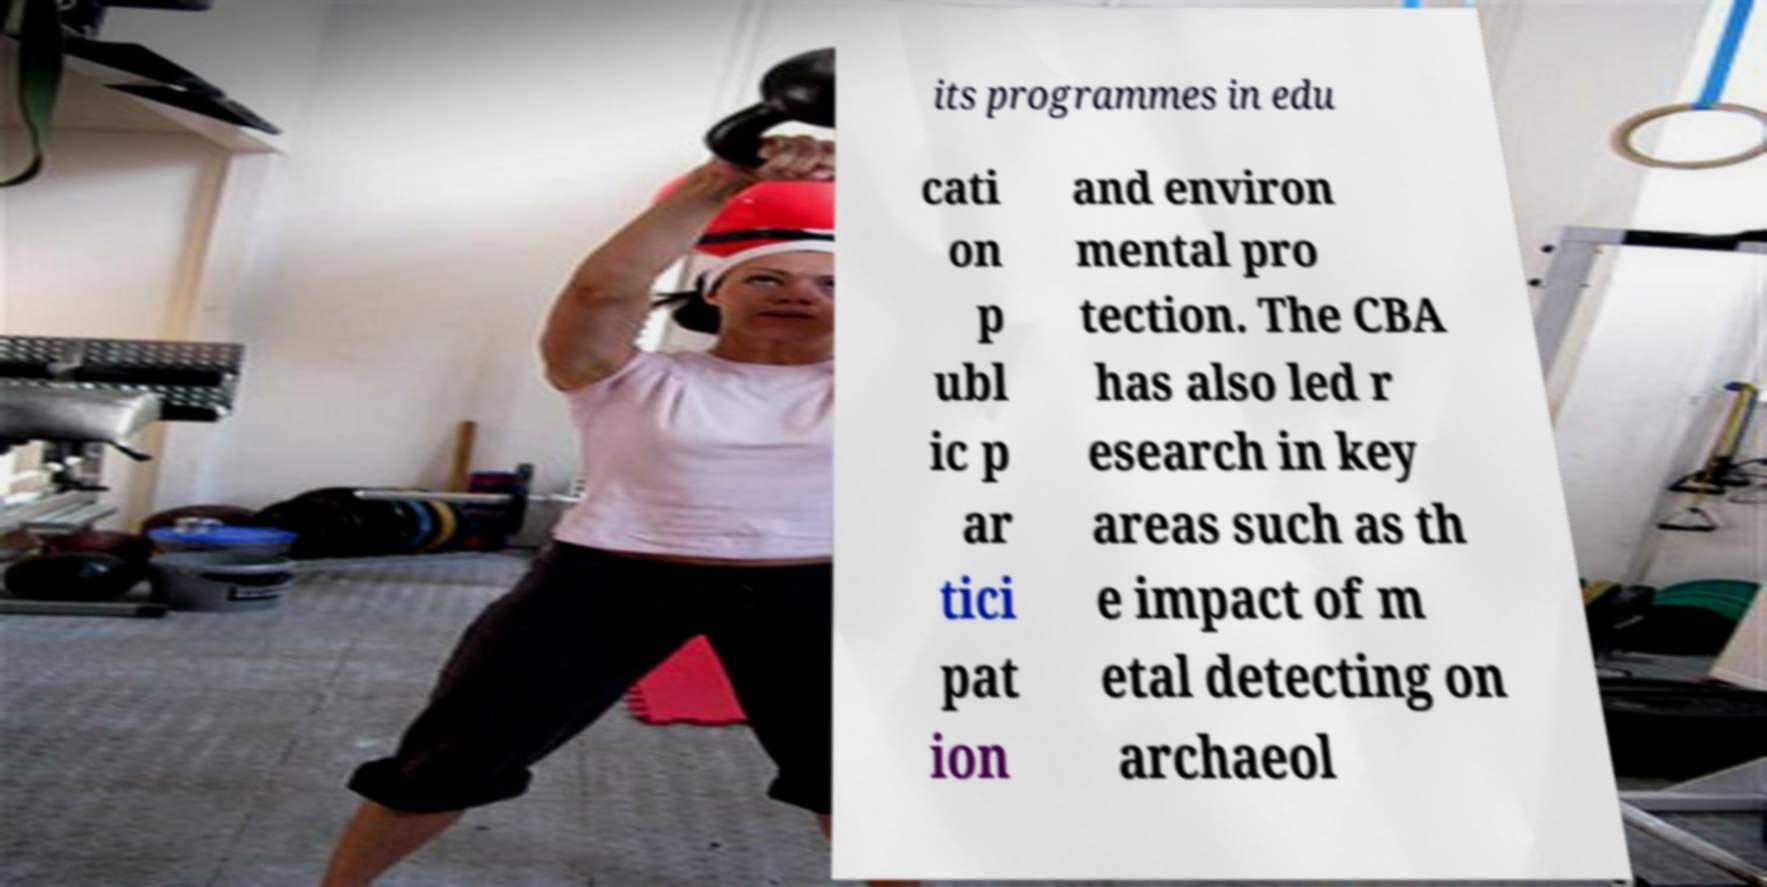Could you extract and type out the text from this image? its programmes in edu cati on p ubl ic p ar tici pat ion and environ mental pro tection. The CBA has also led r esearch in key areas such as th e impact of m etal detecting on archaeol 